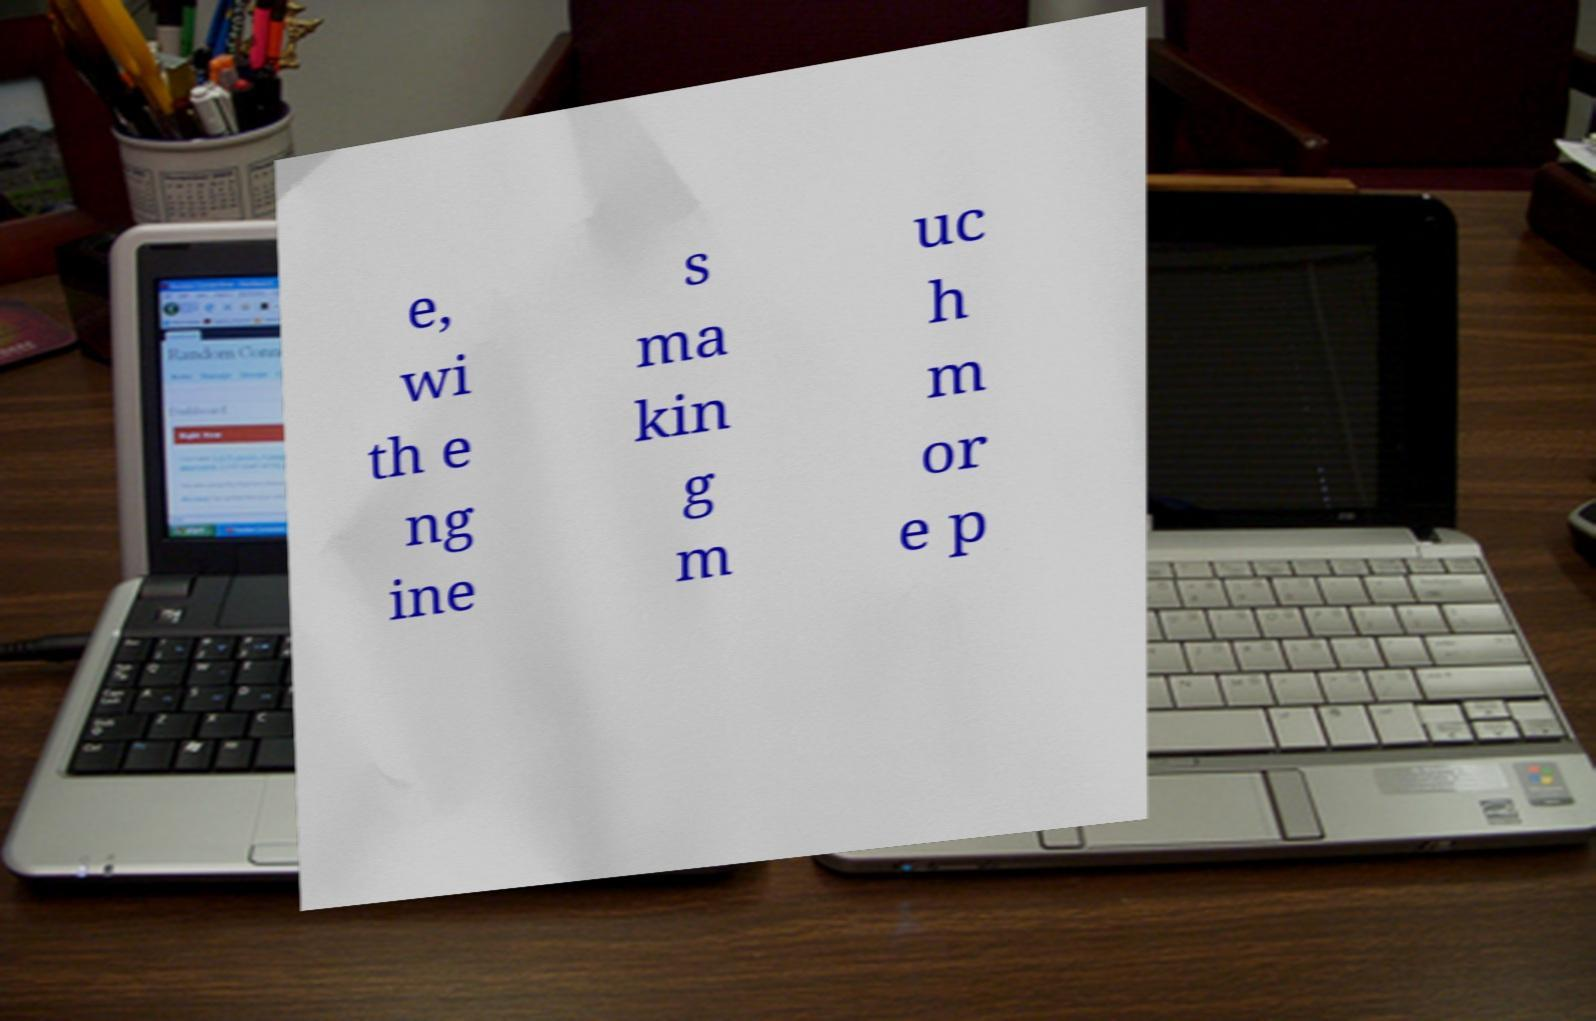Please read and relay the text visible in this image. What does it say? e, wi th e ng ine s ma kin g m uc h m or e p 